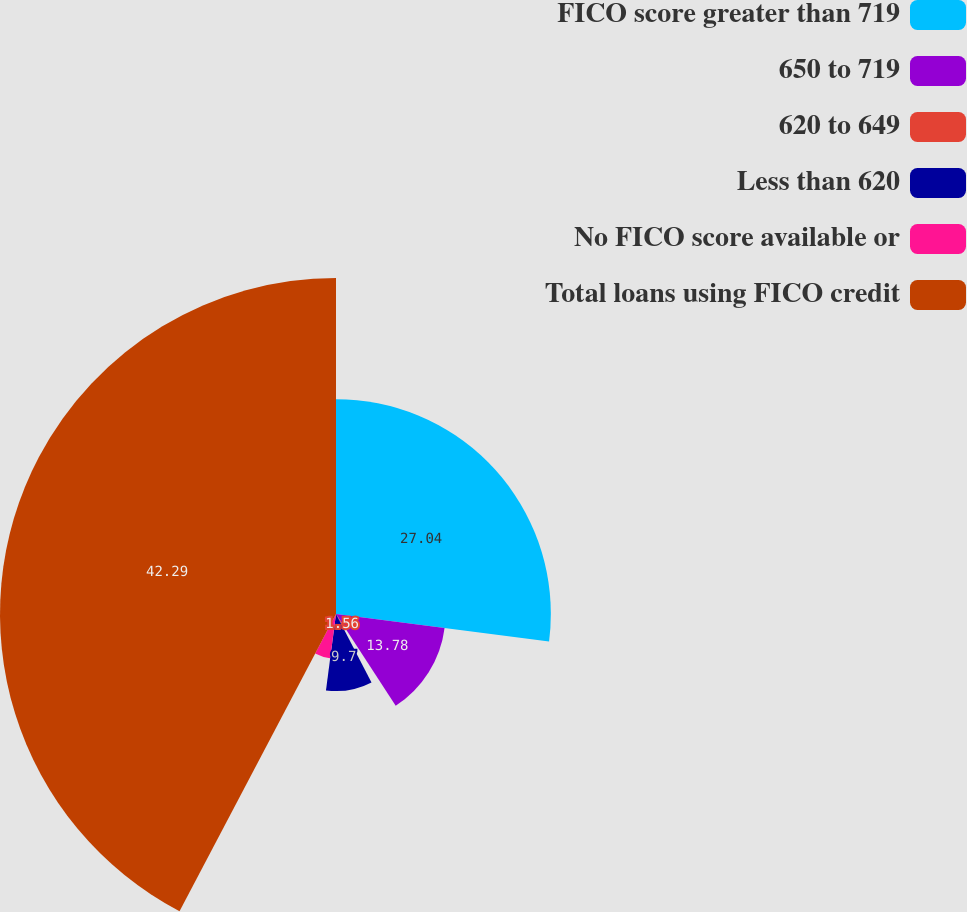Convert chart to OTSL. <chart><loc_0><loc_0><loc_500><loc_500><pie_chart><fcel>FICO score greater than 719<fcel>650 to 719<fcel>620 to 649<fcel>Less than 620<fcel>No FICO score available or<fcel>Total loans using FICO credit<nl><fcel>27.04%<fcel>13.78%<fcel>1.56%<fcel>9.7%<fcel>5.63%<fcel>42.29%<nl></chart> 